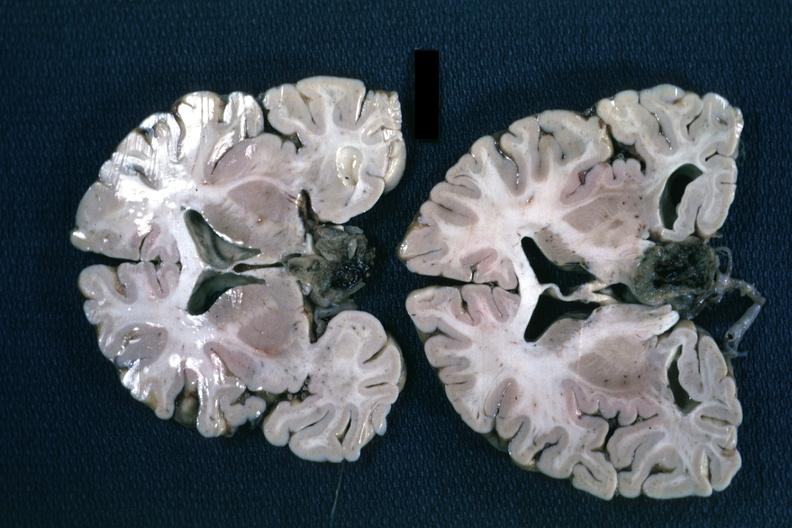s angiogram present?
Answer the question using a single word or phrase. No 